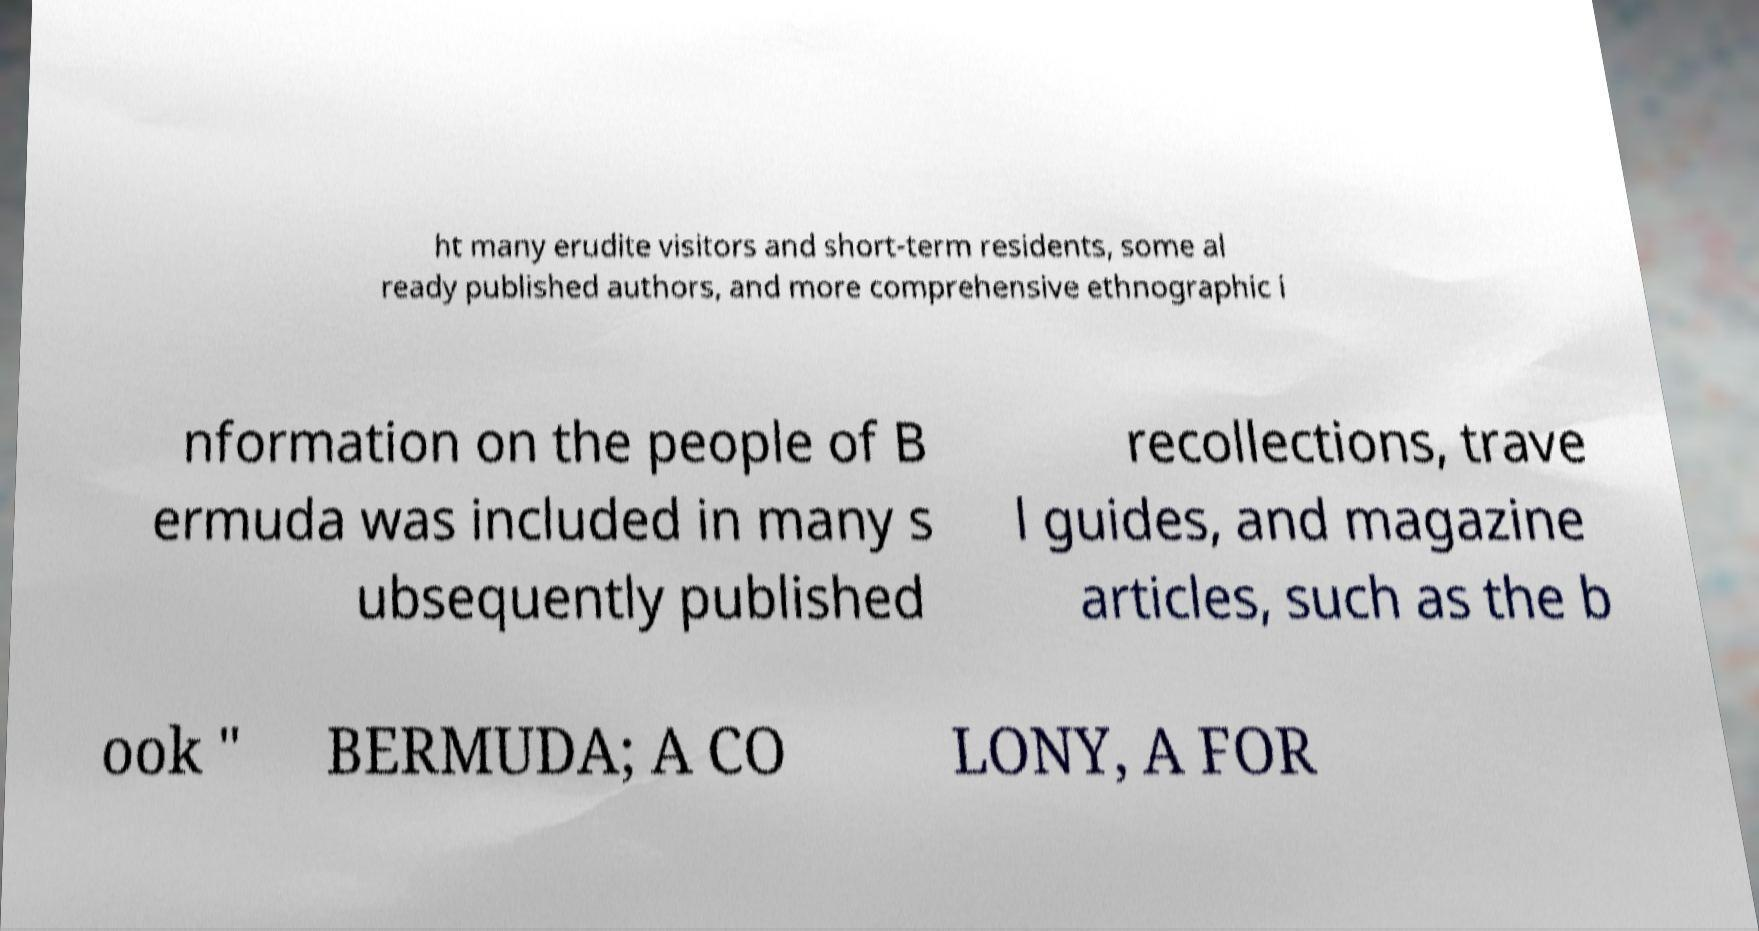I need the written content from this picture converted into text. Can you do that? ht many erudite visitors and short-term residents, some al ready published authors, and more comprehensive ethnographic i nformation on the people of B ermuda was included in many s ubsequently published recollections, trave l guides, and magazine articles, such as the b ook " BERMUDA; A CO LONY, A FOR 